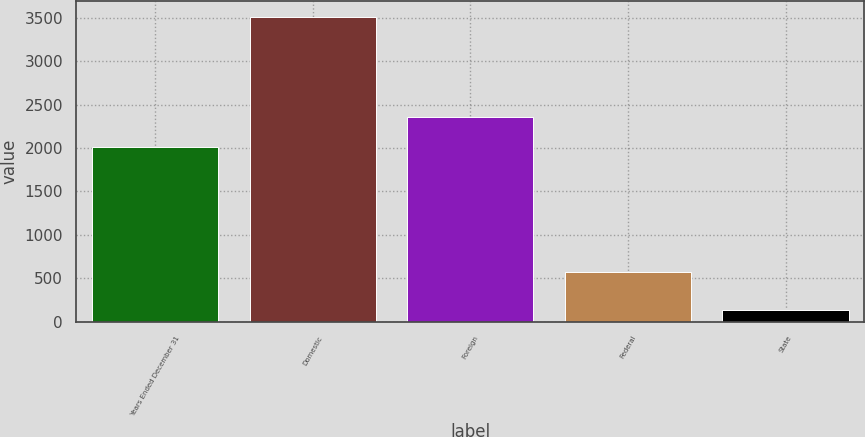Convert chart. <chart><loc_0><loc_0><loc_500><loc_500><bar_chart><fcel>Years Ended December 31<fcel>Domestic<fcel>Foreign<fcel>Federal<fcel>State<nl><fcel>2013<fcel>3513<fcel>2351<fcel>568<fcel>133<nl></chart> 